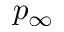<formula> <loc_0><loc_0><loc_500><loc_500>p _ { \infty }</formula> 